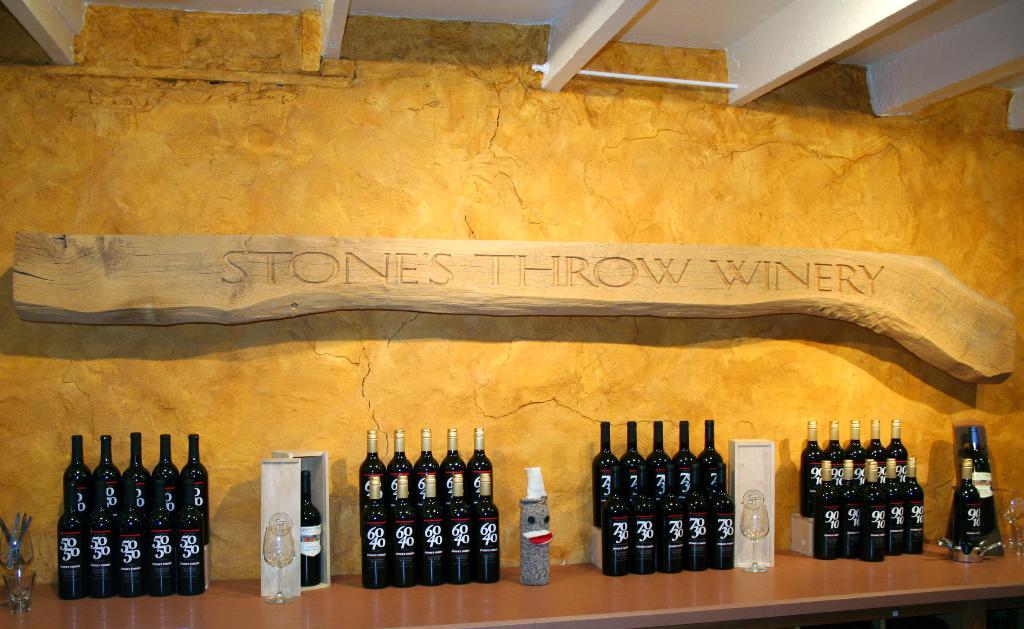What winery is this depicting?
Ensure brevity in your answer.  Stones throw winery. 